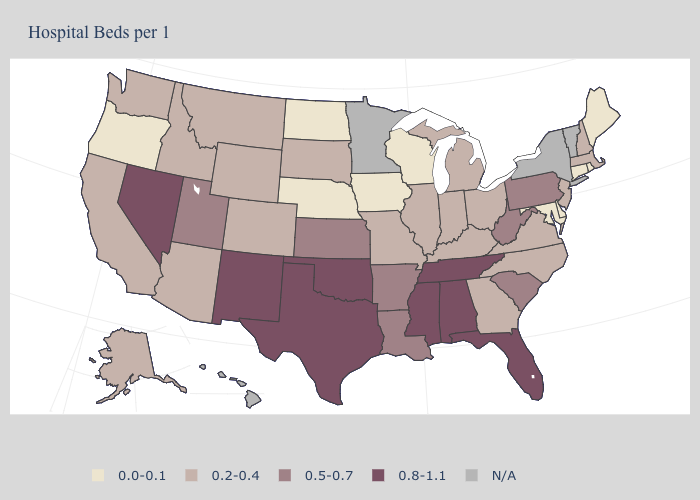What is the value of Nevada?
Answer briefly. 0.8-1.1. Name the states that have a value in the range 0.2-0.4?
Write a very short answer. Alaska, Arizona, California, Colorado, Georgia, Idaho, Illinois, Indiana, Kentucky, Massachusetts, Michigan, Missouri, Montana, New Hampshire, New Jersey, North Carolina, Ohio, South Dakota, Virginia, Washington, Wyoming. Name the states that have a value in the range 0.2-0.4?
Give a very brief answer. Alaska, Arizona, California, Colorado, Georgia, Idaho, Illinois, Indiana, Kentucky, Massachusetts, Michigan, Missouri, Montana, New Hampshire, New Jersey, North Carolina, Ohio, South Dakota, Virginia, Washington, Wyoming. Does California have the lowest value in the West?
Be succinct. No. Which states have the highest value in the USA?
Short answer required. Alabama, Florida, Mississippi, Nevada, New Mexico, Oklahoma, Tennessee, Texas. What is the lowest value in the South?
Be succinct. 0.0-0.1. What is the highest value in the Northeast ?
Give a very brief answer. 0.5-0.7. What is the highest value in the West ?
Write a very short answer. 0.8-1.1. Name the states that have a value in the range 0.5-0.7?
Short answer required. Arkansas, Kansas, Louisiana, Pennsylvania, South Carolina, Utah, West Virginia. What is the highest value in states that border Virginia?
Write a very short answer. 0.8-1.1. Is the legend a continuous bar?
Quick response, please. No. What is the value of Maryland?
Concise answer only. 0.0-0.1. What is the highest value in the Northeast ?
Quick response, please. 0.5-0.7. Among the states that border West Virginia , which have the highest value?
Give a very brief answer. Pennsylvania. What is the lowest value in the USA?
Keep it brief. 0.0-0.1. 